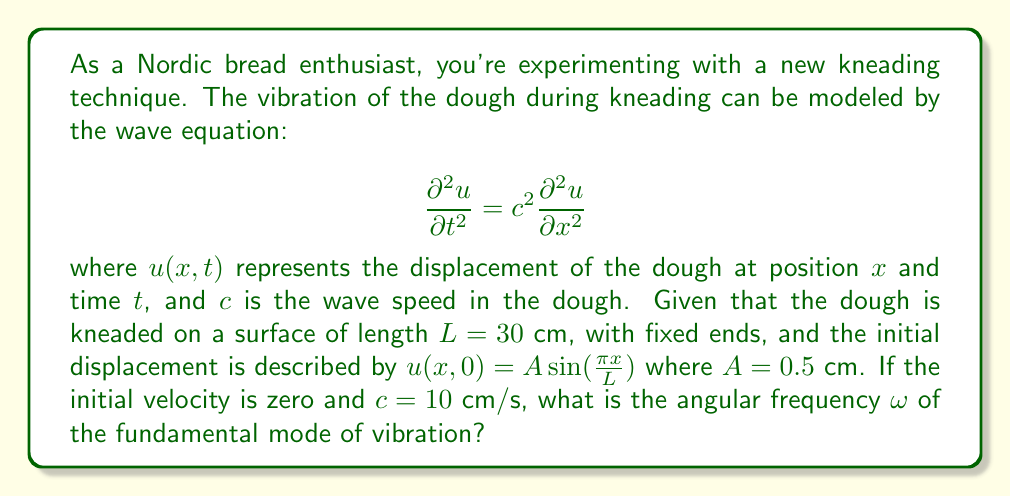Help me with this question. To solve this problem, we'll follow these steps:

1) For a string (or in this case, dough) with fixed ends, the general solution to the wave equation is:

   $$u(x,t) = \sum_{n=1}^{\infty} A_n \sin(\frac{n\pi x}{L}) \cos(\omega_n t)$$

   where $\omega_n$ is the angular frequency of the nth mode.

2) The relationship between $\omega_n$, $c$, $L$, and $n$ is:

   $$\omega_n = \frac{n\pi c}{L}$$

3) The fundamental mode corresponds to $n=1$, so we're looking for $\omega_1$:

   $$\omega_1 = \frac{\pi c}{L}$$

4) We're given:
   - $L = 30$ cm
   - $c = 10$ cm/s

5) Substituting these values:

   $$\omega_1 = \frac{\pi (10 \text{ cm/s})}{30 \text{ cm}} = \frac{\pi}{3} \text{ rad/s}$$

Therefore, the angular frequency of the fundamental mode is $\frac{\pi}{3}$ rad/s.
Answer: $\frac{\pi}{3}$ rad/s 